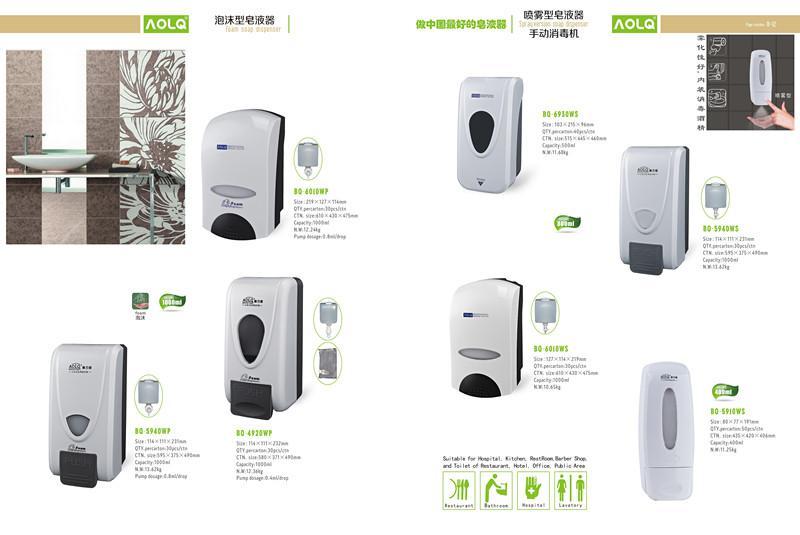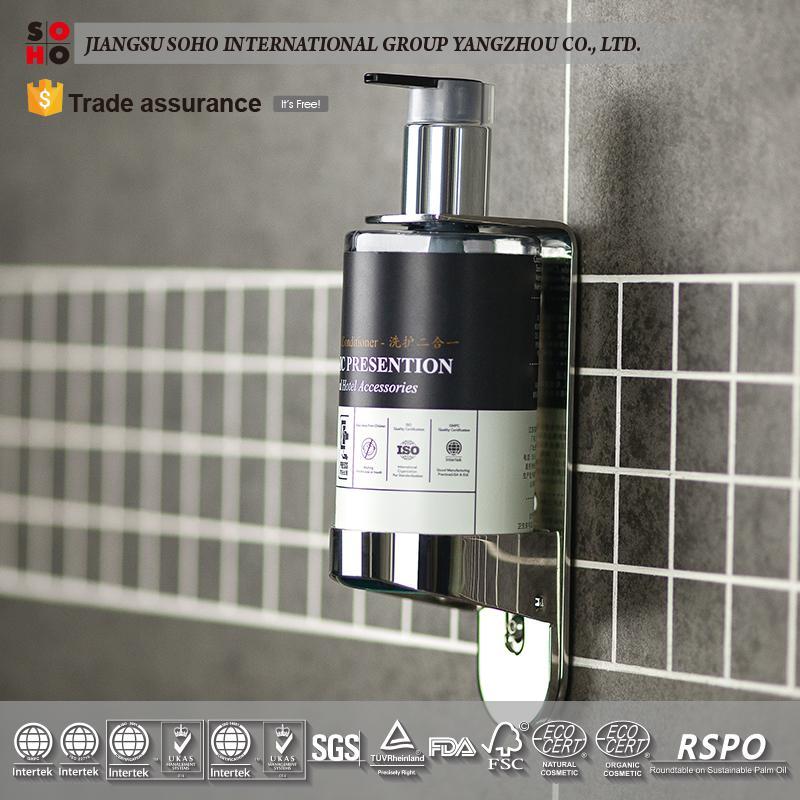The first image is the image on the left, the second image is the image on the right. Assess this claim about the two images: "The left and right image contains a total of three wall soap dispensers.". Correct or not? Answer yes or no. No. 